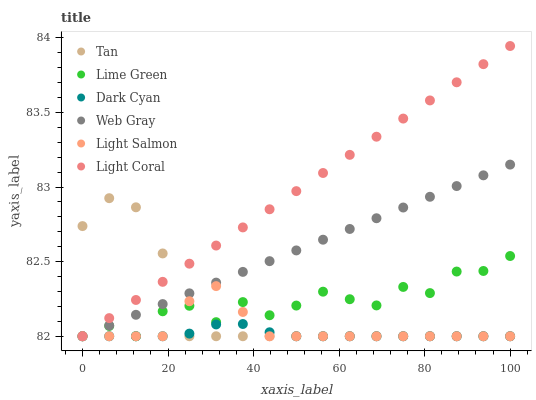Does Dark Cyan have the minimum area under the curve?
Answer yes or no. Yes. Does Light Coral have the maximum area under the curve?
Answer yes or no. Yes. Does Web Gray have the minimum area under the curve?
Answer yes or no. No. Does Web Gray have the maximum area under the curve?
Answer yes or no. No. Is Web Gray the smoothest?
Answer yes or no. Yes. Is Lime Green the roughest?
Answer yes or no. Yes. Is Light Coral the smoothest?
Answer yes or no. No. Is Light Coral the roughest?
Answer yes or no. No. Does Light Salmon have the lowest value?
Answer yes or no. Yes. Does Light Coral have the highest value?
Answer yes or no. Yes. Does Web Gray have the highest value?
Answer yes or no. No. Does Tan intersect Light Salmon?
Answer yes or no. Yes. Is Tan less than Light Salmon?
Answer yes or no. No. Is Tan greater than Light Salmon?
Answer yes or no. No. 